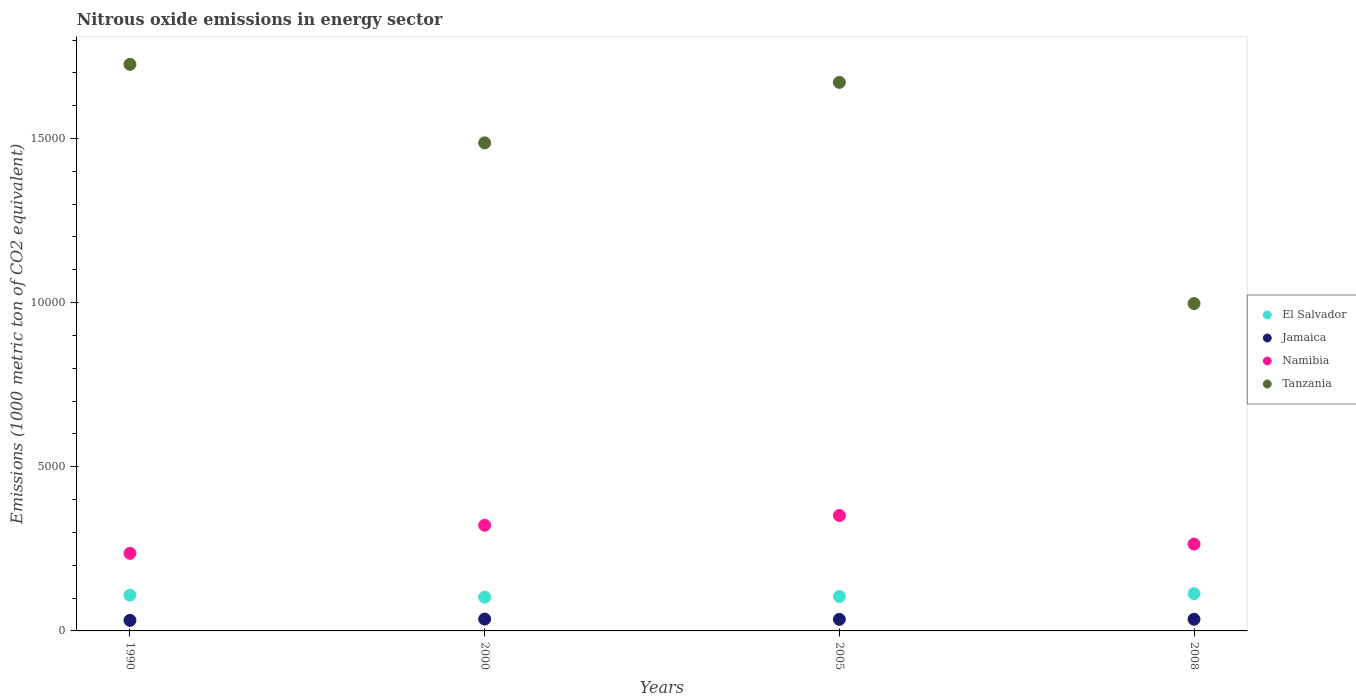How many different coloured dotlines are there?
Your response must be concise. 4. What is the amount of nitrous oxide emitted in Jamaica in 2005?
Provide a short and direct response. 353.5. Across all years, what is the maximum amount of nitrous oxide emitted in Tanzania?
Your answer should be compact. 1.73e+04. Across all years, what is the minimum amount of nitrous oxide emitted in El Salvador?
Provide a succinct answer. 1028. In which year was the amount of nitrous oxide emitted in Tanzania minimum?
Provide a short and direct response. 2008. What is the total amount of nitrous oxide emitted in Namibia in the graph?
Provide a short and direct response. 1.17e+04. What is the difference between the amount of nitrous oxide emitted in El Salvador in 2005 and that in 2008?
Your response must be concise. -85.9. What is the difference between the amount of nitrous oxide emitted in Tanzania in 1990 and the amount of nitrous oxide emitted in El Salvador in 2005?
Ensure brevity in your answer.  1.62e+04. What is the average amount of nitrous oxide emitted in Jamaica per year?
Your answer should be compact. 347.9. In the year 2000, what is the difference between the amount of nitrous oxide emitted in Tanzania and amount of nitrous oxide emitted in El Salvador?
Offer a very short reply. 1.38e+04. What is the ratio of the amount of nitrous oxide emitted in Jamaica in 1990 to that in 2008?
Make the answer very short. 0.91. Is the difference between the amount of nitrous oxide emitted in Tanzania in 2005 and 2008 greater than the difference between the amount of nitrous oxide emitted in El Salvador in 2005 and 2008?
Provide a succinct answer. Yes. What is the difference between the highest and the second highest amount of nitrous oxide emitted in Namibia?
Offer a terse response. 298.1. What is the difference between the highest and the lowest amount of nitrous oxide emitted in Tanzania?
Provide a short and direct response. 7286.2. In how many years, is the amount of nitrous oxide emitted in Namibia greater than the average amount of nitrous oxide emitted in Namibia taken over all years?
Offer a very short reply. 2. Is it the case that in every year, the sum of the amount of nitrous oxide emitted in Jamaica and amount of nitrous oxide emitted in Tanzania  is greater than the amount of nitrous oxide emitted in Namibia?
Your answer should be very brief. Yes. Is the amount of nitrous oxide emitted in Namibia strictly greater than the amount of nitrous oxide emitted in El Salvador over the years?
Give a very brief answer. Yes. How many dotlines are there?
Your answer should be very brief. 4. What is the difference between two consecutive major ticks on the Y-axis?
Make the answer very short. 5000. Are the values on the major ticks of Y-axis written in scientific E-notation?
Ensure brevity in your answer.  No. Does the graph contain grids?
Offer a terse response. No. Where does the legend appear in the graph?
Your answer should be compact. Center right. What is the title of the graph?
Make the answer very short. Nitrous oxide emissions in energy sector. Does "Zimbabwe" appear as one of the legend labels in the graph?
Your answer should be compact. No. What is the label or title of the Y-axis?
Give a very brief answer. Emissions (1000 metric ton of CO2 equivalent). What is the Emissions (1000 metric ton of CO2 equivalent) in El Salvador in 1990?
Offer a very short reply. 1088.8. What is the Emissions (1000 metric ton of CO2 equivalent) in Jamaica in 1990?
Your answer should be compact. 321.7. What is the Emissions (1000 metric ton of CO2 equivalent) of Namibia in 1990?
Your answer should be compact. 2363.8. What is the Emissions (1000 metric ton of CO2 equivalent) in Tanzania in 1990?
Give a very brief answer. 1.73e+04. What is the Emissions (1000 metric ton of CO2 equivalent) in El Salvador in 2000?
Keep it short and to the point. 1028. What is the Emissions (1000 metric ton of CO2 equivalent) in Jamaica in 2000?
Ensure brevity in your answer.  361.6. What is the Emissions (1000 metric ton of CO2 equivalent) in Namibia in 2000?
Your answer should be very brief. 3218.7. What is the Emissions (1000 metric ton of CO2 equivalent) in Tanzania in 2000?
Your response must be concise. 1.49e+04. What is the Emissions (1000 metric ton of CO2 equivalent) of El Salvador in 2005?
Offer a very short reply. 1049.1. What is the Emissions (1000 metric ton of CO2 equivalent) of Jamaica in 2005?
Provide a short and direct response. 353.5. What is the Emissions (1000 metric ton of CO2 equivalent) of Namibia in 2005?
Your answer should be compact. 3516.8. What is the Emissions (1000 metric ton of CO2 equivalent) in Tanzania in 2005?
Keep it short and to the point. 1.67e+04. What is the Emissions (1000 metric ton of CO2 equivalent) in El Salvador in 2008?
Your response must be concise. 1135. What is the Emissions (1000 metric ton of CO2 equivalent) in Jamaica in 2008?
Make the answer very short. 354.8. What is the Emissions (1000 metric ton of CO2 equivalent) in Namibia in 2008?
Provide a short and direct response. 2645.5. What is the Emissions (1000 metric ton of CO2 equivalent) of Tanzania in 2008?
Provide a succinct answer. 9971.9. Across all years, what is the maximum Emissions (1000 metric ton of CO2 equivalent) of El Salvador?
Give a very brief answer. 1135. Across all years, what is the maximum Emissions (1000 metric ton of CO2 equivalent) of Jamaica?
Provide a succinct answer. 361.6. Across all years, what is the maximum Emissions (1000 metric ton of CO2 equivalent) in Namibia?
Make the answer very short. 3516.8. Across all years, what is the maximum Emissions (1000 metric ton of CO2 equivalent) of Tanzania?
Offer a very short reply. 1.73e+04. Across all years, what is the minimum Emissions (1000 metric ton of CO2 equivalent) of El Salvador?
Offer a terse response. 1028. Across all years, what is the minimum Emissions (1000 metric ton of CO2 equivalent) of Jamaica?
Ensure brevity in your answer.  321.7. Across all years, what is the minimum Emissions (1000 metric ton of CO2 equivalent) in Namibia?
Make the answer very short. 2363.8. Across all years, what is the minimum Emissions (1000 metric ton of CO2 equivalent) in Tanzania?
Your answer should be very brief. 9971.9. What is the total Emissions (1000 metric ton of CO2 equivalent) of El Salvador in the graph?
Ensure brevity in your answer.  4300.9. What is the total Emissions (1000 metric ton of CO2 equivalent) in Jamaica in the graph?
Provide a succinct answer. 1391.6. What is the total Emissions (1000 metric ton of CO2 equivalent) in Namibia in the graph?
Give a very brief answer. 1.17e+04. What is the total Emissions (1000 metric ton of CO2 equivalent) of Tanzania in the graph?
Your answer should be compact. 5.88e+04. What is the difference between the Emissions (1000 metric ton of CO2 equivalent) of El Salvador in 1990 and that in 2000?
Your response must be concise. 60.8. What is the difference between the Emissions (1000 metric ton of CO2 equivalent) in Jamaica in 1990 and that in 2000?
Provide a short and direct response. -39.9. What is the difference between the Emissions (1000 metric ton of CO2 equivalent) of Namibia in 1990 and that in 2000?
Ensure brevity in your answer.  -854.9. What is the difference between the Emissions (1000 metric ton of CO2 equivalent) in Tanzania in 1990 and that in 2000?
Ensure brevity in your answer.  2391.3. What is the difference between the Emissions (1000 metric ton of CO2 equivalent) in El Salvador in 1990 and that in 2005?
Your response must be concise. 39.7. What is the difference between the Emissions (1000 metric ton of CO2 equivalent) in Jamaica in 1990 and that in 2005?
Keep it short and to the point. -31.8. What is the difference between the Emissions (1000 metric ton of CO2 equivalent) of Namibia in 1990 and that in 2005?
Provide a succinct answer. -1153. What is the difference between the Emissions (1000 metric ton of CO2 equivalent) of Tanzania in 1990 and that in 2005?
Make the answer very short. 548.2. What is the difference between the Emissions (1000 metric ton of CO2 equivalent) of El Salvador in 1990 and that in 2008?
Keep it short and to the point. -46.2. What is the difference between the Emissions (1000 metric ton of CO2 equivalent) of Jamaica in 1990 and that in 2008?
Give a very brief answer. -33.1. What is the difference between the Emissions (1000 metric ton of CO2 equivalent) of Namibia in 1990 and that in 2008?
Offer a terse response. -281.7. What is the difference between the Emissions (1000 metric ton of CO2 equivalent) of Tanzania in 1990 and that in 2008?
Offer a very short reply. 7286.2. What is the difference between the Emissions (1000 metric ton of CO2 equivalent) of El Salvador in 2000 and that in 2005?
Provide a short and direct response. -21.1. What is the difference between the Emissions (1000 metric ton of CO2 equivalent) in Jamaica in 2000 and that in 2005?
Offer a terse response. 8.1. What is the difference between the Emissions (1000 metric ton of CO2 equivalent) of Namibia in 2000 and that in 2005?
Offer a very short reply. -298.1. What is the difference between the Emissions (1000 metric ton of CO2 equivalent) in Tanzania in 2000 and that in 2005?
Keep it short and to the point. -1843.1. What is the difference between the Emissions (1000 metric ton of CO2 equivalent) in El Salvador in 2000 and that in 2008?
Give a very brief answer. -107. What is the difference between the Emissions (1000 metric ton of CO2 equivalent) of Jamaica in 2000 and that in 2008?
Offer a very short reply. 6.8. What is the difference between the Emissions (1000 metric ton of CO2 equivalent) of Namibia in 2000 and that in 2008?
Provide a short and direct response. 573.2. What is the difference between the Emissions (1000 metric ton of CO2 equivalent) in Tanzania in 2000 and that in 2008?
Offer a very short reply. 4894.9. What is the difference between the Emissions (1000 metric ton of CO2 equivalent) in El Salvador in 2005 and that in 2008?
Offer a very short reply. -85.9. What is the difference between the Emissions (1000 metric ton of CO2 equivalent) in Jamaica in 2005 and that in 2008?
Your answer should be very brief. -1.3. What is the difference between the Emissions (1000 metric ton of CO2 equivalent) in Namibia in 2005 and that in 2008?
Make the answer very short. 871.3. What is the difference between the Emissions (1000 metric ton of CO2 equivalent) in Tanzania in 2005 and that in 2008?
Make the answer very short. 6738. What is the difference between the Emissions (1000 metric ton of CO2 equivalent) of El Salvador in 1990 and the Emissions (1000 metric ton of CO2 equivalent) of Jamaica in 2000?
Provide a succinct answer. 727.2. What is the difference between the Emissions (1000 metric ton of CO2 equivalent) in El Salvador in 1990 and the Emissions (1000 metric ton of CO2 equivalent) in Namibia in 2000?
Give a very brief answer. -2129.9. What is the difference between the Emissions (1000 metric ton of CO2 equivalent) of El Salvador in 1990 and the Emissions (1000 metric ton of CO2 equivalent) of Tanzania in 2000?
Provide a succinct answer. -1.38e+04. What is the difference between the Emissions (1000 metric ton of CO2 equivalent) of Jamaica in 1990 and the Emissions (1000 metric ton of CO2 equivalent) of Namibia in 2000?
Offer a very short reply. -2897. What is the difference between the Emissions (1000 metric ton of CO2 equivalent) in Jamaica in 1990 and the Emissions (1000 metric ton of CO2 equivalent) in Tanzania in 2000?
Ensure brevity in your answer.  -1.45e+04. What is the difference between the Emissions (1000 metric ton of CO2 equivalent) in Namibia in 1990 and the Emissions (1000 metric ton of CO2 equivalent) in Tanzania in 2000?
Your response must be concise. -1.25e+04. What is the difference between the Emissions (1000 metric ton of CO2 equivalent) in El Salvador in 1990 and the Emissions (1000 metric ton of CO2 equivalent) in Jamaica in 2005?
Provide a short and direct response. 735.3. What is the difference between the Emissions (1000 metric ton of CO2 equivalent) in El Salvador in 1990 and the Emissions (1000 metric ton of CO2 equivalent) in Namibia in 2005?
Provide a short and direct response. -2428. What is the difference between the Emissions (1000 metric ton of CO2 equivalent) in El Salvador in 1990 and the Emissions (1000 metric ton of CO2 equivalent) in Tanzania in 2005?
Your response must be concise. -1.56e+04. What is the difference between the Emissions (1000 metric ton of CO2 equivalent) in Jamaica in 1990 and the Emissions (1000 metric ton of CO2 equivalent) in Namibia in 2005?
Your answer should be very brief. -3195.1. What is the difference between the Emissions (1000 metric ton of CO2 equivalent) in Jamaica in 1990 and the Emissions (1000 metric ton of CO2 equivalent) in Tanzania in 2005?
Your answer should be very brief. -1.64e+04. What is the difference between the Emissions (1000 metric ton of CO2 equivalent) of Namibia in 1990 and the Emissions (1000 metric ton of CO2 equivalent) of Tanzania in 2005?
Make the answer very short. -1.43e+04. What is the difference between the Emissions (1000 metric ton of CO2 equivalent) of El Salvador in 1990 and the Emissions (1000 metric ton of CO2 equivalent) of Jamaica in 2008?
Ensure brevity in your answer.  734. What is the difference between the Emissions (1000 metric ton of CO2 equivalent) of El Salvador in 1990 and the Emissions (1000 metric ton of CO2 equivalent) of Namibia in 2008?
Your response must be concise. -1556.7. What is the difference between the Emissions (1000 metric ton of CO2 equivalent) of El Salvador in 1990 and the Emissions (1000 metric ton of CO2 equivalent) of Tanzania in 2008?
Give a very brief answer. -8883.1. What is the difference between the Emissions (1000 metric ton of CO2 equivalent) in Jamaica in 1990 and the Emissions (1000 metric ton of CO2 equivalent) in Namibia in 2008?
Your response must be concise. -2323.8. What is the difference between the Emissions (1000 metric ton of CO2 equivalent) of Jamaica in 1990 and the Emissions (1000 metric ton of CO2 equivalent) of Tanzania in 2008?
Make the answer very short. -9650.2. What is the difference between the Emissions (1000 metric ton of CO2 equivalent) of Namibia in 1990 and the Emissions (1000 metric ton of CO2 equivalent) of Tanzania in 2008?
Keep it short and to the point. -7608.1. What is the difference between the Emissions (1000 metric ton of CO2 equivalent) of El Salvador in 2000 and the Emissions (1000 metric ton of CO2 equivalent) of Jamaica in 2005?
Your answer should be very brief. 674.5. What is the difference between the Emissions (1000 metric ton of CO2 equivalent) in El Salvador in 2000 and the Emissions (1000 metric ton of CO2 equivalent) in Namibia in 2005?
Offer a terse response. -2488.8. What is the difference between the Emissions (1000 metric ton of CO2 equivalent) of El Salvador in 2000 and the Emissions (1000 metric ton of CO2 equivalent) of Tanzania in 2005?
Keep it short and to the point. -1.57e+04. What is the difference between the Emissions (1000 metric ton of CO2 equivalent) in Jamaica in 2000 and the Emissions (1000 metric ton of CO2 equivalent) in Namibia in 2005?
Ensure brevity in your answer.  -3155.2. What is the difference between the Emissions (1000 metric ton of CO2 equivalent) of Jamaica in 2000 and the Emissions (1000 metric ton of CO2 equivalent) of Tanzania in 2005?
Keep it short and to the point. -1.63e+04. What is the difference between the Emissions (1000 metric ton of CO2 equivalent) in Namibia in 2000 and the Emissions (1000 metric ton of CO2 equivalent) in Tanzania in 2005?
Give a very brief answer. -1.35e+04. What is the difference between the Emissions (1000 metric ton of CO2 equivalent) in El Salvador in 2000 and the Emissions (1000 metric ton of CO2 equivalent) in Jamaica in 2008?
Keep it short and to the point. 673.2. What is the difference between the Emissions (1000 metric ton of CO2 equivalent) of El Salvador in 2000 and the Emissions (1000 metric ton of CO2 equivalent) of Namibia in 2008?
Your answer should be compact. -1617.5. What is the difference between the Emissions (1000 metric ton of CO2 equivalent) of El Salvador in 2000 and the Emissions (1000 metric ton of CO2 equivalent) of Tanzania in 2008?
Your answer should be very brief. -8943.9. What is the difference between the Emissions (1000 metric ton of CO2 equivalent) in Jamaica in 2000 and the Emissions (1000 metric ton of CO2 equivalent) in Namibia in 2008?
Give a very brief answer. -2283.9. What is the difference between the Emissions (1000 metric ton of CO2 equivalent) in Jamaica in 2000 and the Emissions (1000 metric ton of CO2 equivalent) in Tanzania in 2008?
Give a very brief answer. -9610.3. What is the difference between the Emissions (1000 metric ton of CO2 equivalent) of Namibia in 2000 and the Emissions (1000 metric ton of CO2 equivalent) of Tanzania in 2008?
Provide a short and direct response. -6753.2. What is the difference between the Emissions (1000 metric ton of CO2 equivalent) of El Salvador in 2005 and the Emissions (1000 metric ton of CO2 equivalent) of Jamaica in 2008?
Your answer should be very brief. 694.3. What is the difference between the Emissions (1000 metric ton of CO2 equivalent) in El Salvador in 2005 and the Emissions (1000 metric ton of CO2 equivalent) in Namibia in 2008?
Your answer should be very brief. -1596.4. What is the difference between the Emissions (1000 metric ton of CO2 equivalent) in El Salvador in 2005 and the Emissions (1000 metric ton of CO2 equivalent) in Tanzania in 2008?
Your answer should be compact. -8922.8. What is the difference between the Emissions (1000 metric ton of CO2 equivalent) of Jamaica in 2005 and the Emissions (1000 metric ton of CO2 equivalent) of Namibia in 2008?
Your answer should be compact. -2292. What is the difference between the Emissions (1000 metric ton of CO2 equivalent) in Jamaica in 2005 and the Emissions (1000 metric ton of CO2 equivalent) in Tanzania in 2008?
Ensure brevity in your answer.  -9618.4. What is the difference between the Emissions (1000 metric ton of CO2 equivalent) of Namibia in 2005 and the Emissions (1000 metric ton of CO2 equivalent) of Tanzania in 2008?
Provide a short and direct response. -6455.1. What is the average Emissions (1000 metric ton of CO2 equivalent) of El Salvador per year?
Offer a terse response. 1075.22. What is the average Emissions (1000 metric ton of CO2 equivalent) in Jamaica per year?
Your answer should be very brief. 347.9. What is the average Emissions (1000 metric ton of CO2 equivalent) of Namibia per year?
Offer a terse response. 2936.2. What is the average Emissions (1000 metric ton of CO2 equivalent) in Tanzania per year?
Offer a very short reply. 1.47e+04. In the year 1990, what is the difference between the Emissions (1000 metric ton of CO2 equivalent) of El Salvador and Emissions (1000 metric ton of CO2 equivalent) of Jamaica?
Ensure brevity in your answer.  767.1. In the year 1990, what is the difference between the Emissions (1000 metric ton of CO2 equivalent) in El Salvador and Emissions (1000 metric ton of CO2 equivalent) in Namibia?
Your answer should be compact. -1275. In the year 1990, what is the difference between the Emissions (1000 metric ton of CO2 equivalent) of El Salvador and Emissions (1000 metric ton of CO2 equivalent) of Tanzania?
Make the answer very short. -1.62e+04. In the year 1990, what is the difference between the Emissions (1000 metric ton of CO2 equivalent) in Jamaica and Emissions (1000 metric ton of CO2 equivalent) in Namibia?
Make the answer very short. -2042.1. In the year 1990, what is the difference between the Emissions (1000 metric ton of CO2 equivalent) of Jamaica and Emissions (1000 metric ton of CO2 equivalent) of Tanzania?
Keep it short and to the point. -1.69e+04. In the year 1990, what is the difference between the Emissions (1000 metric ton of CO2 equivalent) of Namibia and Emissions (1000 metric ton of CO2 equivalent) of Tanzania?
Make the answer very short. -1.49e+04. In the year 2000, what is the difference between the Emissions (1000 metric ton of CO2 equivalent) of El Salvador and Emissions (1000 metric ton of CO2 equivalent) of Jamaica?
Your response must be concise. 666.4. In the year 2000, what is the difference between the Emissions (1000 metric ton of CO2 equivalent) in El Salvador and Emissions (1000 metric ton of CO2 equivalent) in Namibia?
Offer a terse response. -2190.7. In the year 2000, what is the difference between the Emissions (1000 metric ton of CO2 equivalent) of El Salvador and Emissions (1000 metric ton of CO2 equivalent) of Tanzania?
Your answer should be compact. -1.38e+04. In the year 2000, what is the difference between the Emissions (1000 metric ton of CO2 equivalent) in Jamaica and Emissions (1000 metric ton of CO2 equivalent) in Namibia?
Your answer should be very brief. -2857.1. In the year 2000, what is the difference between the Emissions (1000 metric ton of CO2 equivalent) of Jamaica and Emissions (1000 metric ton of CO2 equivalent) of Tanzania?
Ensure brevity in your answer.  -1.45e+04. In the year 2000, what is the difference between the Emissions (1000 metric ton of CO2 equivalent) of Namibia and Emissions (1000 metric ton of CO2 equivalent) of Tanzania?
Provide a short and direct response. -1.16e+04. In the year 2005, what is the difference between the Emissions (1000 metric ton of CO2 equivalent) of El Salvador and Emissions (1000 metric ton of CO2 equivalent) of Jamaica?
Provide a succinct answer. 695.6. In the year 2005, what is the difference between the Emissions (1000 metric ton of CO2 equivalent) in El Salvador and Emissions (1000 metric ton of CO2 equivalent) in Namibia?
Make the answer very short. -2467.7. In the year 2005, what is the difference between the Emissions (1000 metric ton of CO2 equivalent) of El Salvador and Emissions (1000 metric ton of CO2 equivalent) of Tanzania?
Keep it short and to the point. -1.57e+04. In the year 2005, what is the difference between the Emissions (1000 metric ton of CO2 equivalent) in Jamaica and Emissions (1000 metric ton of CO2 equivalent) in Namibia?
Ensure brevity in your answer.  -3163.3. In the year 2005, what is the difference between the Emissions (1000 metric ton of CO2 equivalent) in Jamaica and Emissions (1000 metric ton of CO2 equivalent) in Tanzania?
Offer a very short reply. -1.64e+04. In the year 2005, what is the difference between the Emissions (1000 metric ton of CO2 equivalent) of Namibia and Emissions (1000 metric ton of CO2 equivalent) of Tanzania?
Make the answer very short. -1.32e+04. In the year 2008, what is the difference between the Emissions (1000 metric ton of CO2 equivalent) in El Salvador and Emissions (1000 metric ton of CO2 equivalent) in Jamaica?
Give a very brief answer. 780.2. In the year 2008, what is the difference between the Emissions (1000 metric ton of CO2 equivalent) of El Salvador and Emissions (1000 metric ton of CO2 equivalent) of Namibia?
Your response must be concise. -1510.5. In the year 2008, what is the difference between the Emissions (1000 metric ton of CO2 equivalent) of El Salvador and Emissions (1000 metric ton of CO2 equivalent) of Tanzania?
Give a very brief answer. -8836.9. In the year 2008, what is the difference between the Emissions (1000 metric ton of CO2 equivalent) of Jamaica and Emissions (1000 metric ton of CO2 equivalent) of Namibia?
Make the answer very short. -2290.7. In the year 2008, what is the difference between the Emissions (1000 metric ton of CO2 equivalent) of Jamaica and Emissions (1000 metric ton of CO2 equivalent) of Tanzania?
Your answer should be very brief. -9617.1. In the year 2008, what is the difference between the Emissions (1000 metric ton of CO2 equivalent) in Namibia and Emissions (1000 metric ton of CO2 equivalent) in Tanzania?
Offer a very short reply. -7326.4. What is the ratio of the Emissions (1000 metric ton of CO2 equivalent) in El Salvador in 1990 to that in 2000?
Provide a short and direct response. 1.06. What is the ratio of the Emissions (1000 metric ton of CO2 equivalent) in Jamaica in 1990 to that in 2000?
Give a very brief answer. 0.89. What is the ratio of the Emissions (1000 metric ton of CO2 equivalent) in Namibia in 1990 to that in 2000?
Ensure brevity in your answer.  0.73. What is the ratio of the Emissions (1000 metric ton of CO2 equivalent) of Tanzania in 1990 to that in 2000?
Provide a succinct answer. 1.16. What is the ratio of the Emissions (1000 metric ton of CO2 equivalent) of El Salvador in 1990 to that in 2005?
Ensure brevity in your answer.  1.04. What is the ratio of the Emissions (1000 metric ton of CO2 equivalent) of Jamaica in 1990 to that in 2005?
Your response must be concise. 0.91. What is the ratio of the Emissions (1000 metric ton of CO2 equivalent) in Namibia in 1990 to that in 2005?
Keep it short and to the point. 0.67. What is the ratio of the Emissions (1000 metric ton of CO2 equivalent) of Tanzania in 1990 to that in 2005?
Your response must be concise. 1.03. What is the ratio of the Emissions (1000 metric ton of CO2 equivalent) in El Salvador in 1990 to that in 2008?
Provide a short and direct response. 0.96. What is the ratio of the Emissions (1000 metric ton of CO2 equivalent) of Jamaica in 1990 to that in 2008?
Your answer should be very brief. 0.91. What is the ratio of the Emissions (1000 metric ton of CO2 equivalent) in Namibia in 1990 to that in 2008?
Keep it short and to the point. 0.89. What is the ratio of the Emissions (1000 metric ton of CO2 equivalent) of Tanzania in 1990 to that in 2008?
Ensure brevity in your answer.  1.73. What is the ratio of the Emissions (1000 metric ton of CO2 equivalent) in El Salvador in 2000 to that in 2005?
Ensure brevity in your answer.  0.98. What is the ratio of the Emissions (1000 metric ton of CO2 equivalent) of Jamaica in 2000 to that in 2005?
Ensure brevity in your answer.  1.02. What is the ratio of the Emissions (1000 metric ton of CO2 equivalent) of Namibia in 2000 to that in 2005?
Your answer should be very brief. 0.92. What is the ratio of the Emissions (1000 metric ton of CO2 equivalent) of Tanzania in 2000 to that in 2005?
Provide a succinct answer. 0.89. What is the ratio of the Emissions (1000 metric ton of CO2 equivalent) in El Salvador in 2000 to that in 2008?
Keep it short and to the point. 0.91. What is the ratio of the Emissions (1000 metric ton of CO2 equivalent) of Jamaica in 2000 to that in 2008?
Give a very brief answer. 1.02. What is the ratio of the Emissions (1000 metric ton of CO2 equivalent) in Namibia in 2000 to that in 2008?
Your response must be concise. 1.22. What is the ratio of the Emissions (1000 metric ton of CO2 equivalent) in Tanzania in 2000 to that in 2008?
Ensure brevity in your answer.  1.49. What is the ratio of the Emissions (1000 metric ton of CO2 equivalent) of El Salvador in 2005 to that in 2008?
Make the answer very short. 0.92. What is the ratio of the Emissions (1000 metric ton of CO2 equivalent) in Jamaica in 2005 to that in 2008?
Ensure brevity in your answer.  1. What is the ratio of the Emissions (1000 metric ton of CO2 equivalent) in Namibia in 2005 to that in 2008?
Your answer should be compact. 1.33. What is the ratio of the Emissions (1000 metric ton of CO2 equivalent) in Tanzania in 2005 to that in 2008?
Offer a very short reply. 1.68. What is the difference between the highest and the second highest Emissions (1000 metric ton of CO2 equivalent) of El Salvador?
Make the answer very short. 46.2. What is the difference between the highest and the second highest Emissions (1000 metric ton of CO2 equivalent) in Jamaica?
Offer a very short reply. 6.8. What is the difference between the highest and the second highest Emissions (1000 metric ton of CO2 equivalent) in Namibia?
Your answer should be compact. 298.1. What is the difference between the highest and the second highest Emissions (1000 metric ton of CO2 equivalent) of Tanzania?
Make the answer very short. 548.2. What is the difference between the highest and the lowest Emissions (1000 metric ton of CO2 equivalent) in El Salvador?
Ensure brevity in your answer.  107. What is the difference between the highest and the lowest Emissions (1000 metric ton of CO2 equivalent) of Jamaica?
Provide a short and direct response. 39.9. What is the difference between the highest and the lowest Emissions (1000 metric ton of CO2 equivalent) of Namibia?
Your response must be concise. 1153. What is the difference between the highest and the lowest Emissions (1000 metric ton of CO2 equivalent) of Tanzania?
Offer a terse response. 7286.2. 